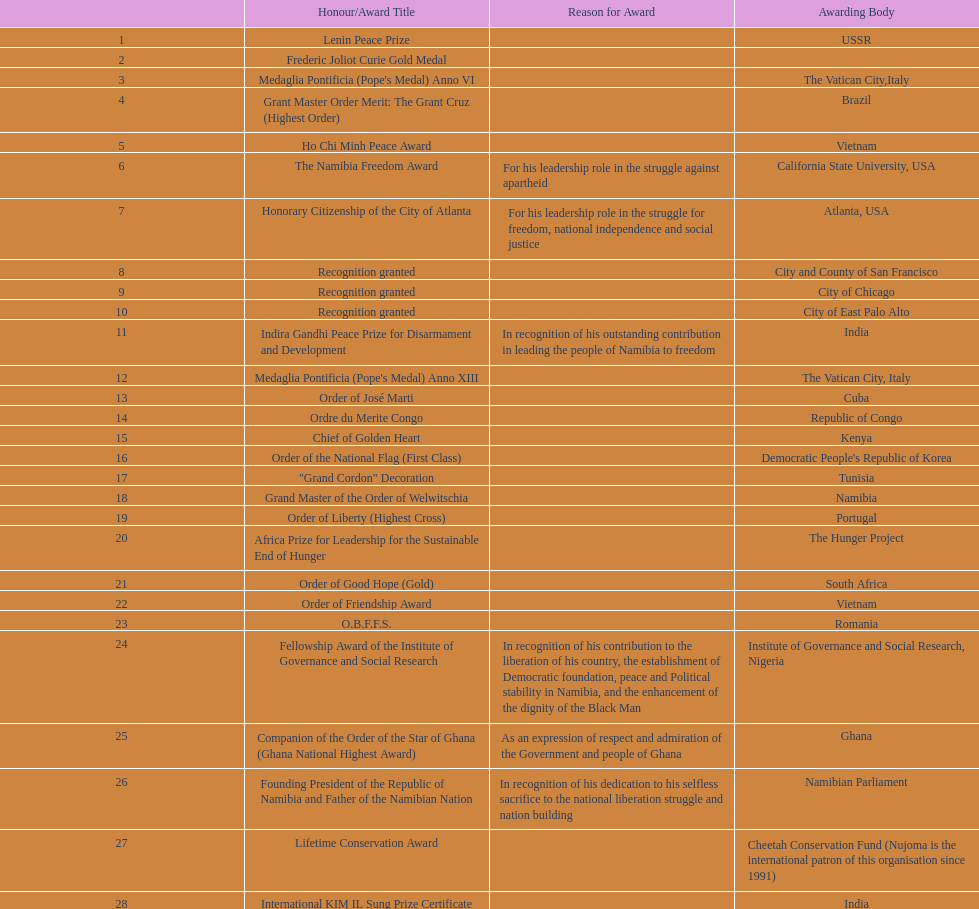What was the name of the honor/award title given after the international kim il sung prize certificate? Sir Seretse Khama SADC Meda. 